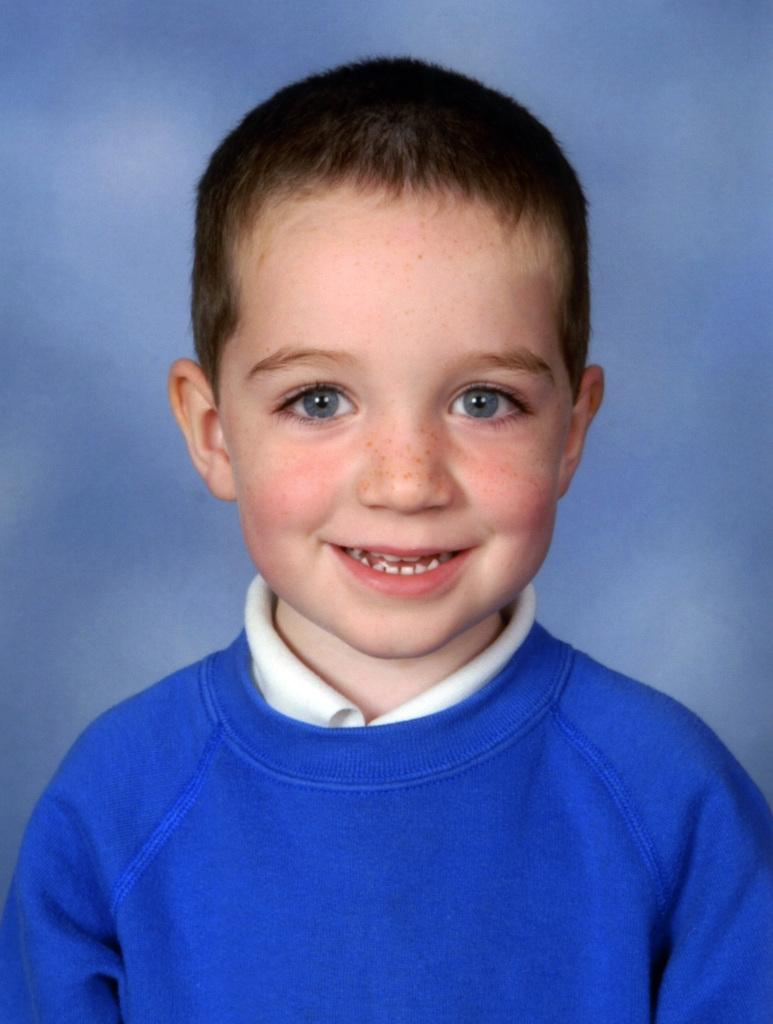What is the main subject of the image? The main subject of the image is a child. What is the child doing in the image? The child is smiling in the image. What is the child wearing in the image? The child is wearing a blue t-shirt in the image. What territory is the child measuring in the image? There is no indication in the image that the child is measuring any territory. 